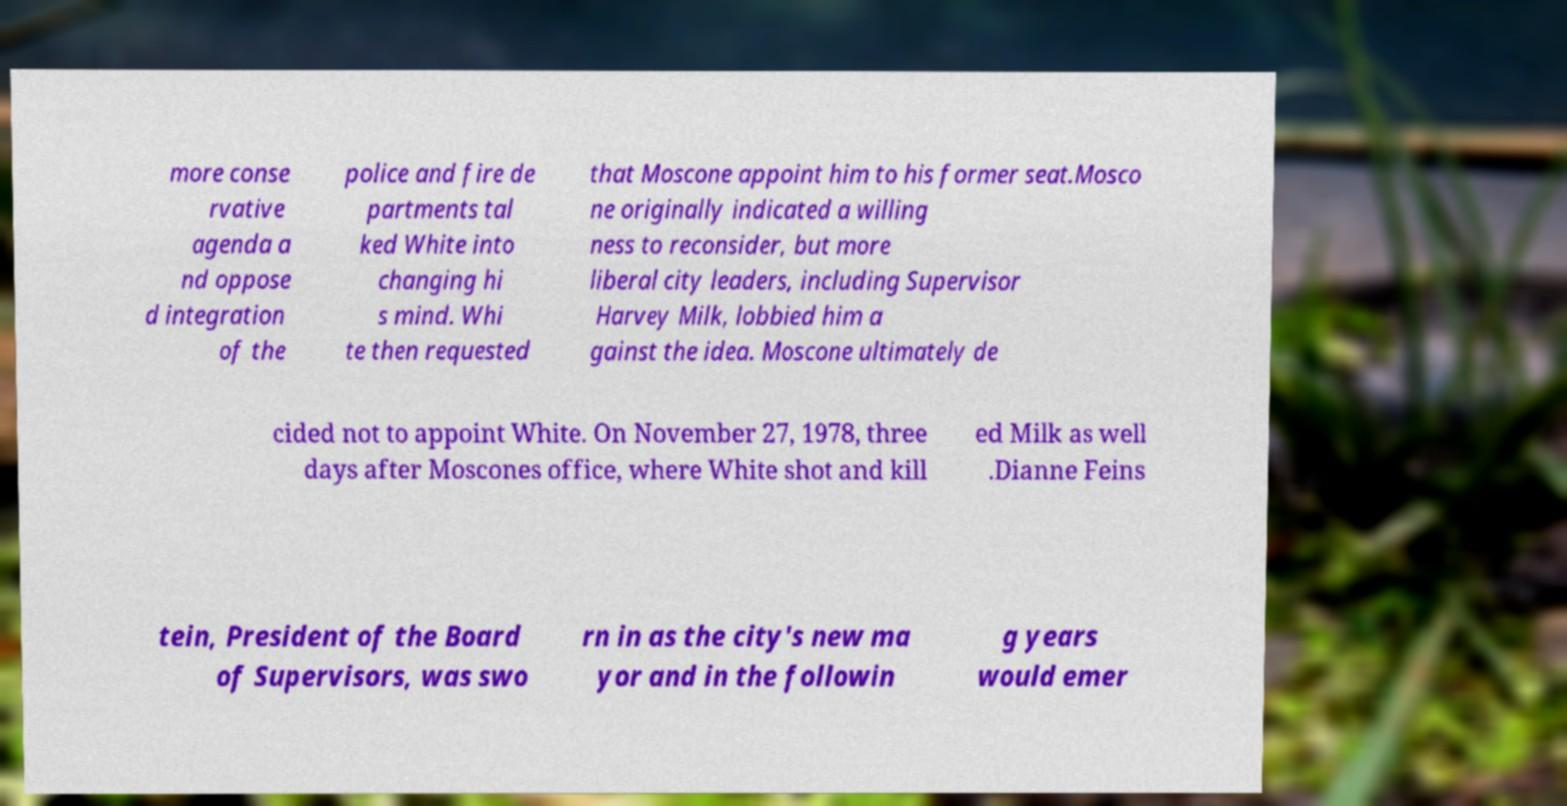For documentation purposes, I need the text within this image transcribed. Could you provide that? more conse rvative agenda a nd oppose d integration of the police and fire de partments tal ked White into changing hi s mind. Whi te then requested that Moscone appoint him to his former seat.Mosco ne originally indicated a willing ness to reconsider, but more liberal city leaders, including Supervisor Harvey Milk, lobbied him a gainst the idea. Moscone ultimately de cided not to appoint White. On November 27, 1978, three days after Moscones office, where White shot and kill ed Milk as well .Dianne Feins tein, President of the Board of Supervisors, was swo rn in as the city's new ma yor and in the followin g years would emer 